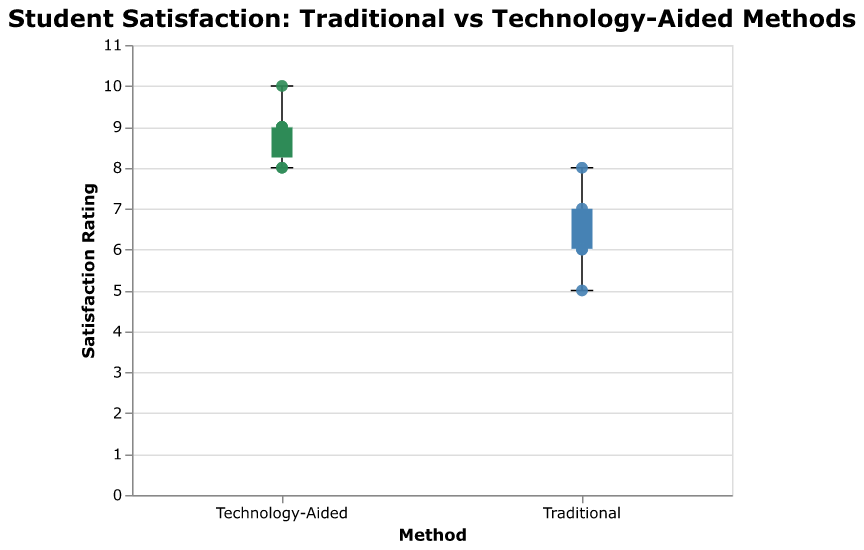What is the title of the plot? The title is located at the top of the figure and reads "Student Satisfaction: Traditional vs Technology-Aided Methods".
Answer: Student Satisfaction: Traditional vs Technology-Aided Methods Which method has higher median satisfaction ratings? The median is shown by the horizontal line inside the box of a box plot. Comparing the two, the Technology-Aided method's median line is higher than that of traditional methods.
Answer: Technology-Aided What is the minimum student satisfaction rating for the traditional method? The minimum value in a box plot is represented by the lower end of the whisker. For the traditional method, this is at a rating of 5.
Answer: 5 What is the interquartile range (IQR) for the Technology-Aided method? The IQR is the range between the first quartile (Q1) and the third quartile (Q3). For the Technology-Aided method, Q1 is 8 and Q3 is 9. Thus, IQR = 9 - 8.
Answer: 1 How many students rated the traditional method with a score of 7? The scatter points overlaying the box plot represent individual ratings. Counting the points at a rating of 7 for the traditional method, there are two students.
Answer: 2 Which method has a greater spread in student satisfaction ratings? The spread can be compared by looking at the range from the minimum to the maximum rating in the box plots. The traditional method has a wider spread, from 5 to 8, while the Technology-Aided method ranges from 8 to 10.
Answer: Traditional What is the maximum student satisfaction rating for the Technology-Aided method? The maximum value in a box plot is shown by the upper end of the whisker. For the Technology-Aided method, this is at a rating of 10.
Answer: 10 How many students rated the Technology-Aided method with a score of 9? Counting the scatter points at a rating of 9 for the Technology-Aided method, there are six students.
Answer: 6 Compare the range of student satisfaction ratings between the two methods. The range is the difference between the maximum and minimum values. For the traditional method, it is 8 - 5 = 3. For the Technology-Aided method, it is 10 - 8 = 2. Thus, the traditional method has a larger range.
Answer: 3 (Traditional), 2 (Technology-Aided) Which method has higher satisfaction ratings overall? Observing the distribution of ratings, the Technology-Aided method not only has a higher median but also consistently higher ratings (8 to 10) compared to the traditional method (5 to 8).
Answer: Technology-Aided 